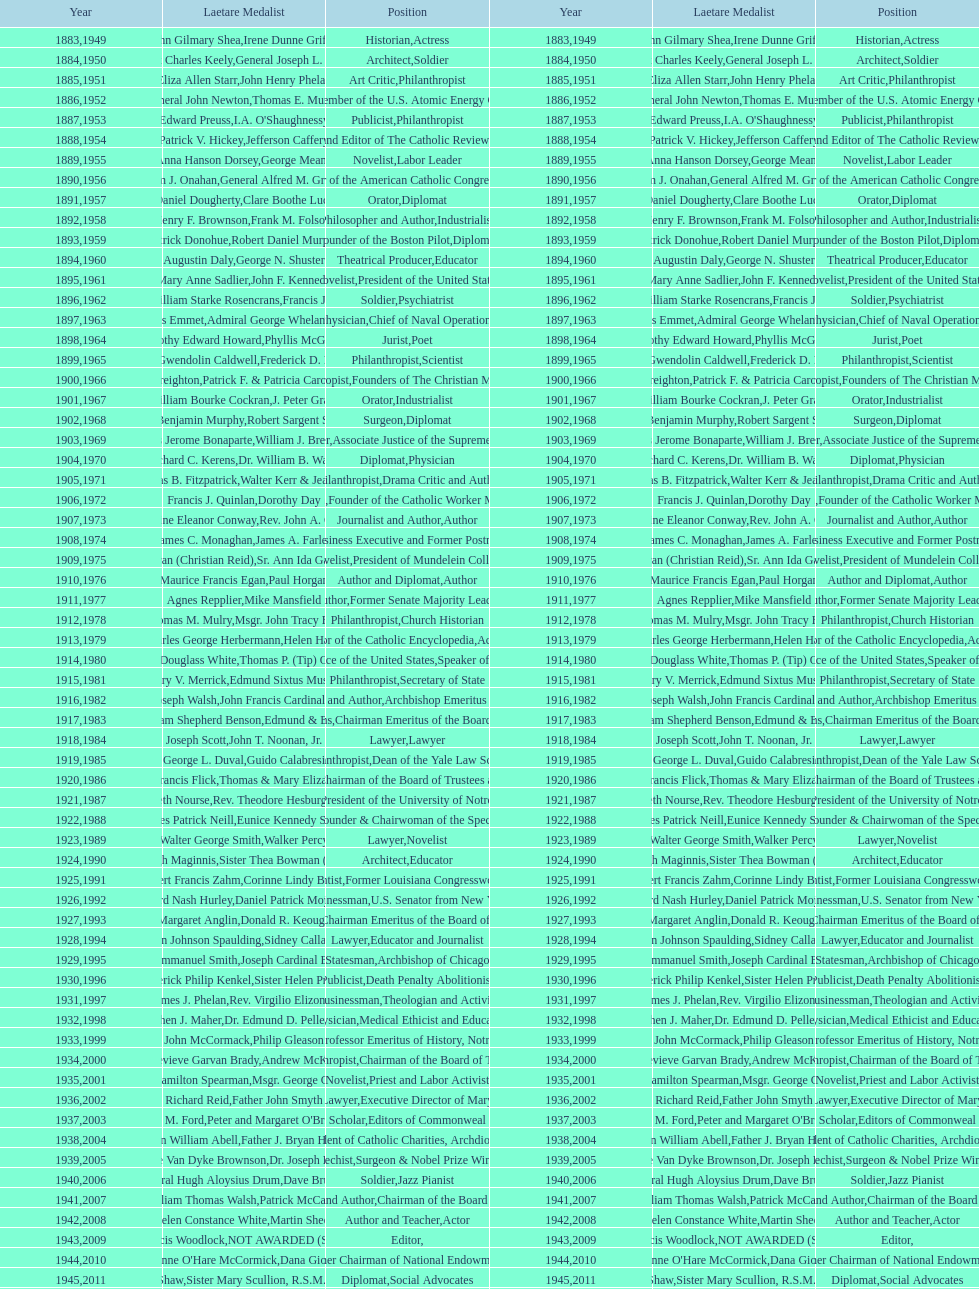How many are or were journalists? 5. 